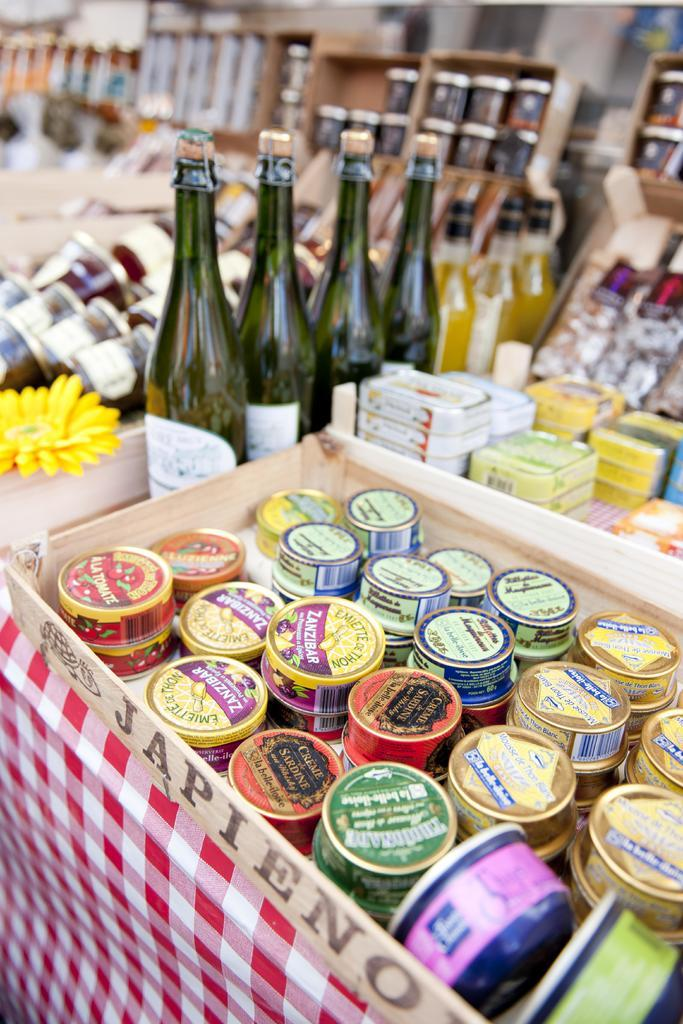<image>
Render a clear and concise summary of the photo. Several things for sale in a wooden box that says Japieno on the side. 